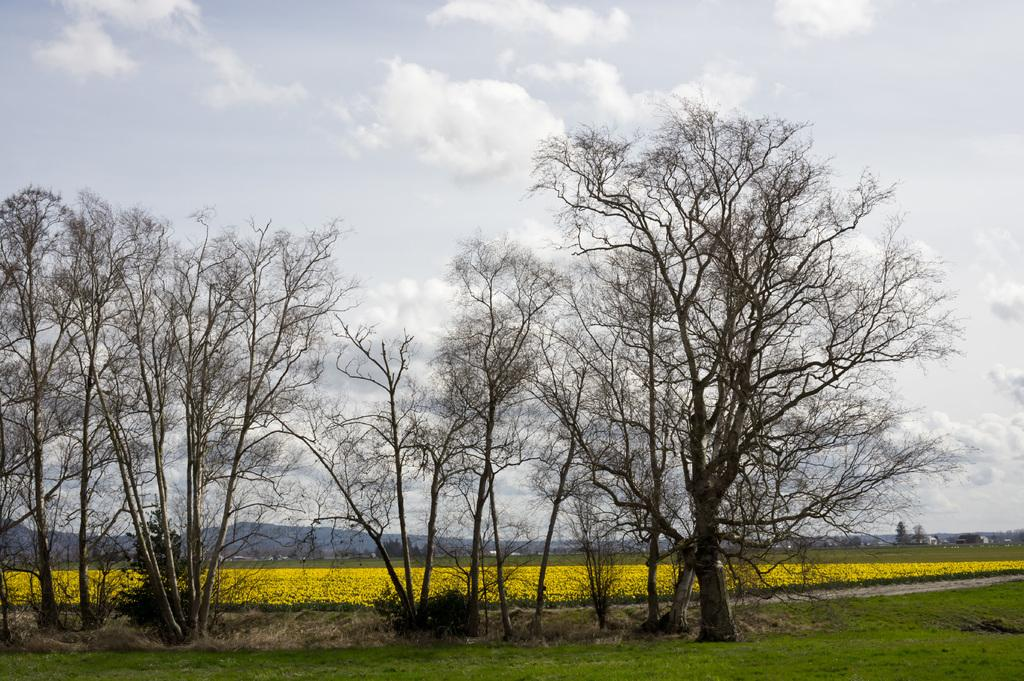What type of vegetation can be seen in the image? There are trees in the image. What type of landscape is visible in the image? There is a field in the image. What can be seen in the sky in the image? There are clouds in the sky. What is visible at the top of the image? The sky is visible at the top of the image. What is visible at the bottom of the image? The ground is visible at the bottom of the image. What type of meat is being grilled in the image? There is no meat or grill present in the image; it features trees, a field, clouds, and the sky. What direction are the trees facing in the image? The direction the trees are facing cannot be determined from the image, as they are stationary objects. 